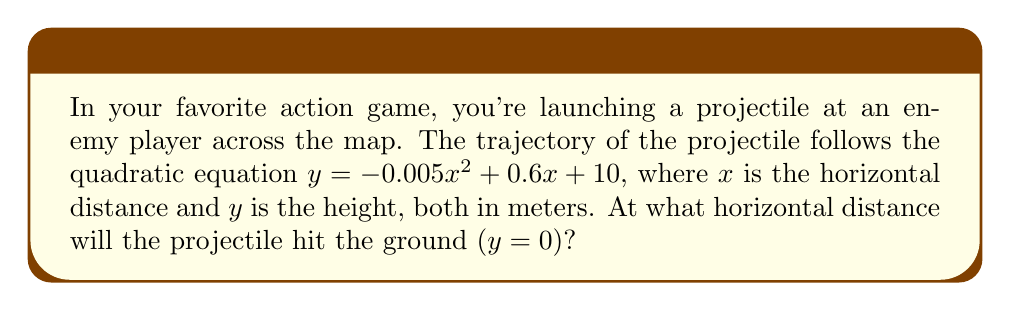Could you help me with this problem? To solve this problem, we need to find the roots of the quadratic equation:

1) Set $y = 0$ to find where the projectile hits the ground:
   $0 = -0.005x^2 + 0.6x + 10$

2) Rearrange the equation to standard form:
   $0.005x^2 - 0.6x - 10 = 0$

3) Identify the coefficients:
   $a = 0.005$, $b = -0.6$, $c = -10$

4) Use the quadratic formula: $x = \frac{-b \pm \sqrt{b^2 - 4ac}}{2a}$

5) Substitute the values:
   $x = \frac{0.6 \pm \sqrt{(-0.6)^2 - 4(0.005)(-10)}}{2(0.005)}$

6) Simplify:
   $x = \frac{0.6 \pm \sqrt{0.36 + 0.2}}{0.01} = \frac{0.6 \pm \sqrt{0.56}}{0.01}$

7) Calculate:
   $x = \frac{0.6 \pm 0.7483}{0.01} = 60 \pm 74.83$

8) This gives us two solutions:
   $x_1 = 134.83$ meters
   $x_2 = -14.83$ meters

9) Since negative distance doesn't make sense in this context, we discard the negative solution.

Therefore, the projectile will hit the ground at approximately 134.83 meters.
Answer: 134.83 meters 